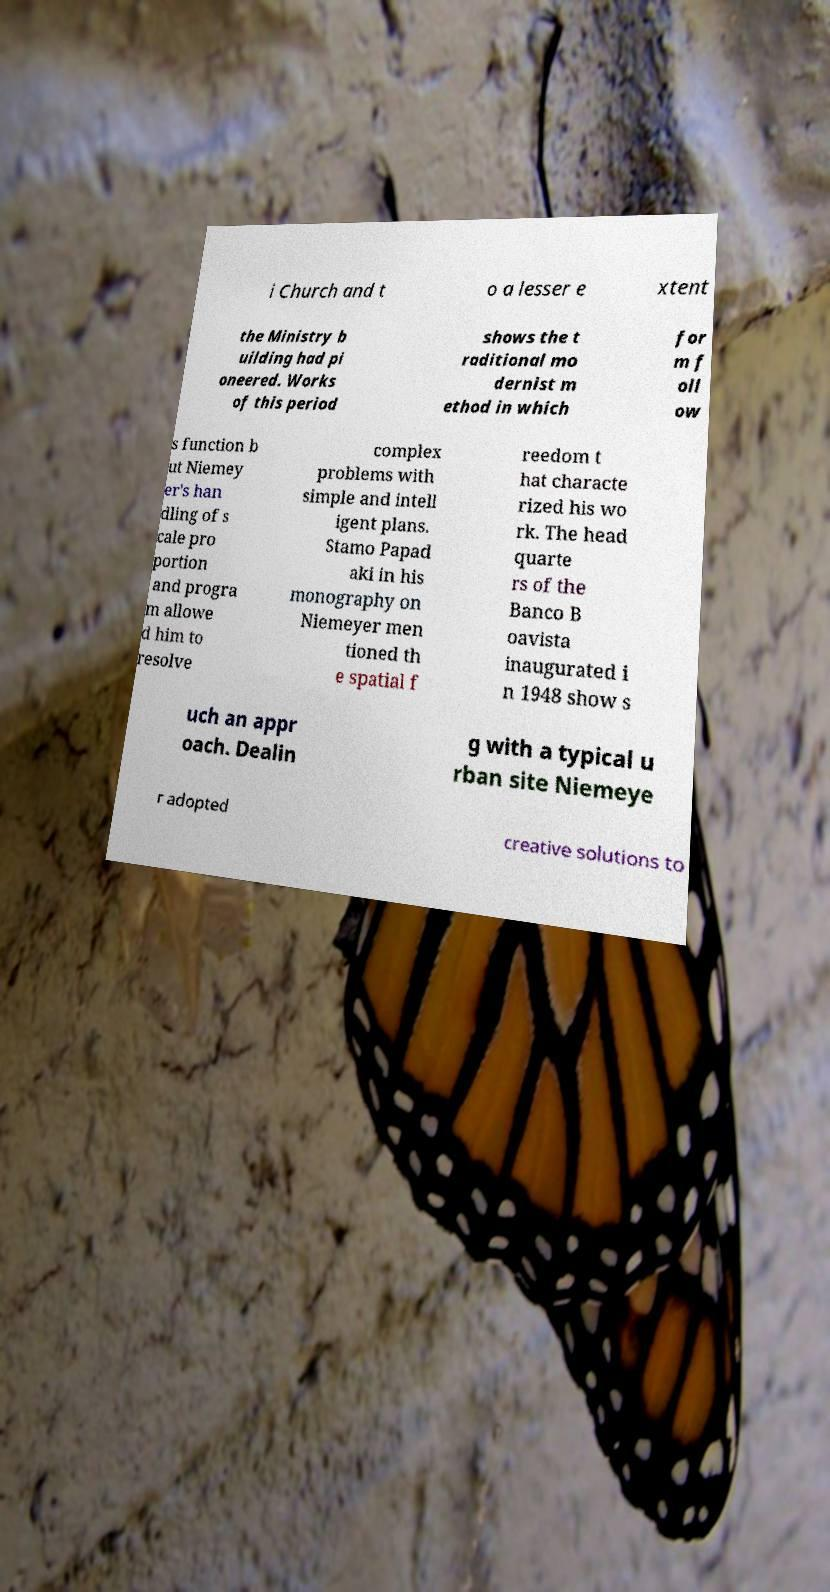There's text embedded in this image that I need extracted. Can you transcribe it verbatim? i Church and t o a lesser e xtent the Ministry b uilding had pi oneered. Works of this period shows the t raditional mo dernist m ethod in which for m f oll ow s function b ut Niemey er's han dling of s cale pro portion and progra m allowe d him to resolve complex problems with simple and intell igent plans. Stamo Papad aki in his monography on Niemeyer men tioned th e spatial f reedom t hat characte rized his wo rk. The head quarte rs of the Banco B oavista inaugurated i n 1948 show s uch an appr oach. Dealin g with a typical u rban site Niemeye r adopted creative solutions to 